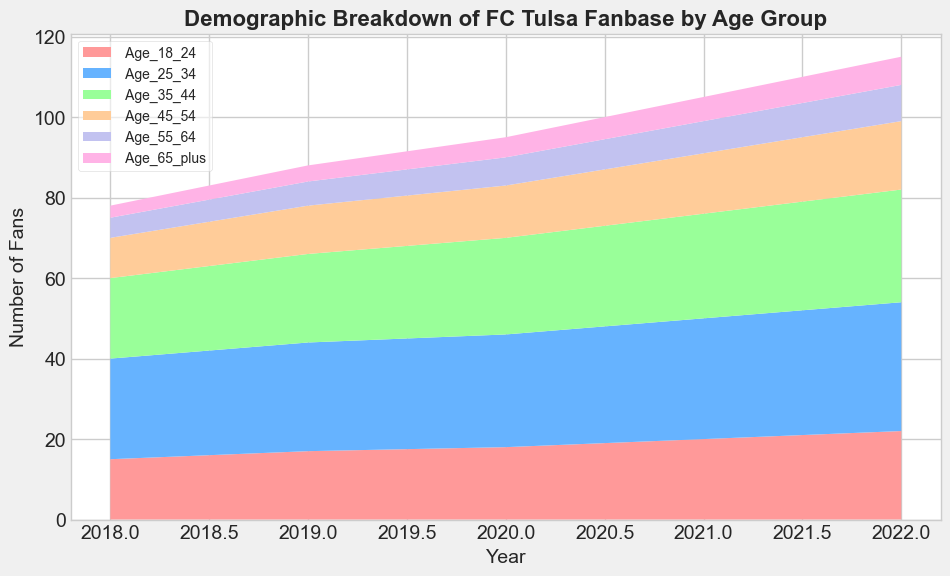What's the highest number of fans in any age group in a single year? The highest number of fans can be found by looking at the peak of any color in the chart. In 2022, the 'Age_25_34' group has the most fans, with 32.
Answer: 32 Which age group saw the largest increase in the number of fans from 2018 to 2022? To find the largest increase, subtract the number of fans in 2018 from 2022 for each age group. For 'Age_18_24', the increase is 22-15=7; for 'Age_25_34', it is 32-25=7; for 'Age_35_44', it is 28-20=8; for 'Age_45_54', it is 17-10=7; for 'Age_55_64', it is 9-5=4; for 'Age_65_plus', it is 7-3=4. The largest increase is in the 'Age_35_44' group with an increase of 8.
Answer: Age_35_44 In which year did the 'Age_25_34' group surpass the 'Age_35_44' group in the number of fans? Look at the 'Age_25_34' and 'Age_35_44' sections of the chart across the years. In 2018 and 2019, 'Age_25_34' is higher. From 2019 onward, 'Age_25_34' continues to be higher, indicating it surpassed 'Age_35_44' before 2018. Therefore, 'Age_25_34' has always been higher.
Answer: Before 2018 Which two age groups had the closest number of fans in the year 2021? Check the values for each age group in 2021. 'Age_18_24' has 20, 'Age_25_34' has 30, 'Age_35_44' has 26, 'Age_45_54' has 15, 'Age_55_64' has 8, and 'Age_65_plus' has 6. The closest numbers are 'Age_45_54' at 15 and 'Age_55_64' at 8.
Answer: Age_45_54 and Age_55_64 What's the total number of fans in all age groups for the year 2020? Sum the number of fans across all age groups for the year 2020: 18 + 28 + 24 + 13 + 7 + 5 = 95.
Answer: 95 Which age group's fanbase size was the smallest in 2022? Look at the size of each age group's section in 2022. 'Age_65_plus' has the smallest number with 7 fans.
Answer: Age_65_plus How did the proportion of 'Age_18_24' compared to 'Age_65_plus' change from 2018 to 2022? For 'Age_18_24' in 2018, it was 15 and for 'Age_65_plus', 3. In 2022, 'Age_18_24' is 22 and 'Age_65_plus', 7. To compare the proportions: In 2018, 'Age_18_24' is 5 times 'Age_65_plus' (15/3), but in 2022, it is a bit more than 3 times (22/7). The proportion decreased.
Answer: Decreased What is the average number of fans in the 'Age_35_44' group over the five years? The numbers for 'Age_35_44' are 20, 22, 24, 26, and 28. Calculate the average: (20 + 22 + 24 + 26 + 28) / 5 = 120 / 5 = 24.
Answer: 24 Which age group consistently had more fans than 'Age_45_54' between 2018 and 2022? Based on the chart, 'Age_18_24', 'Age_25_34', and 'Age_35_44' groups consistently had more fans than 'Age_45_54' for all years.
Answer: Age_18_24, Age_25_34, Age_35_44 